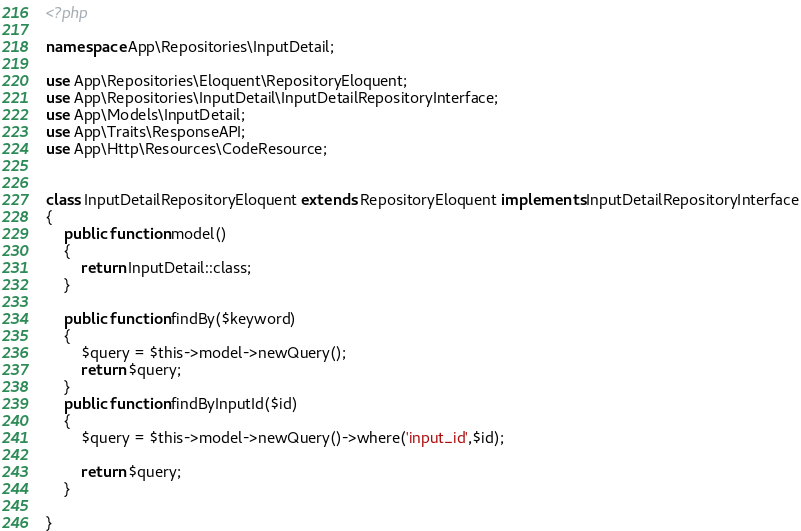<code> <loc_0><loc_0><loc_500><loc_500><_PHP_><?php

namespace App\Repositories\InputDetail;

use App\Repositories\Eloquent\RepositoryEloquent;
use App\Repositories\InputDetail\InputDetailRepositoryInterface;
use App\Models\InputDetail;
use App\Traits\ResponseAPI;
use App\Http\Resources\CodeResource;


class InputDetailRepositoryEloquent extends RepositoryEloquent implements InputDetailRepositoryInterface
{
    public function model()
    {
        return InputDetail::class;
    }

    public function findBy($keyword)
    {
        $query = $this->model->newQuery();
        return $query;
    }
    public function findByInputId($id)
    {
        $query = $this->model->newQuery()->where('input_id',$id);

        return $query;
    }

}
</code> 